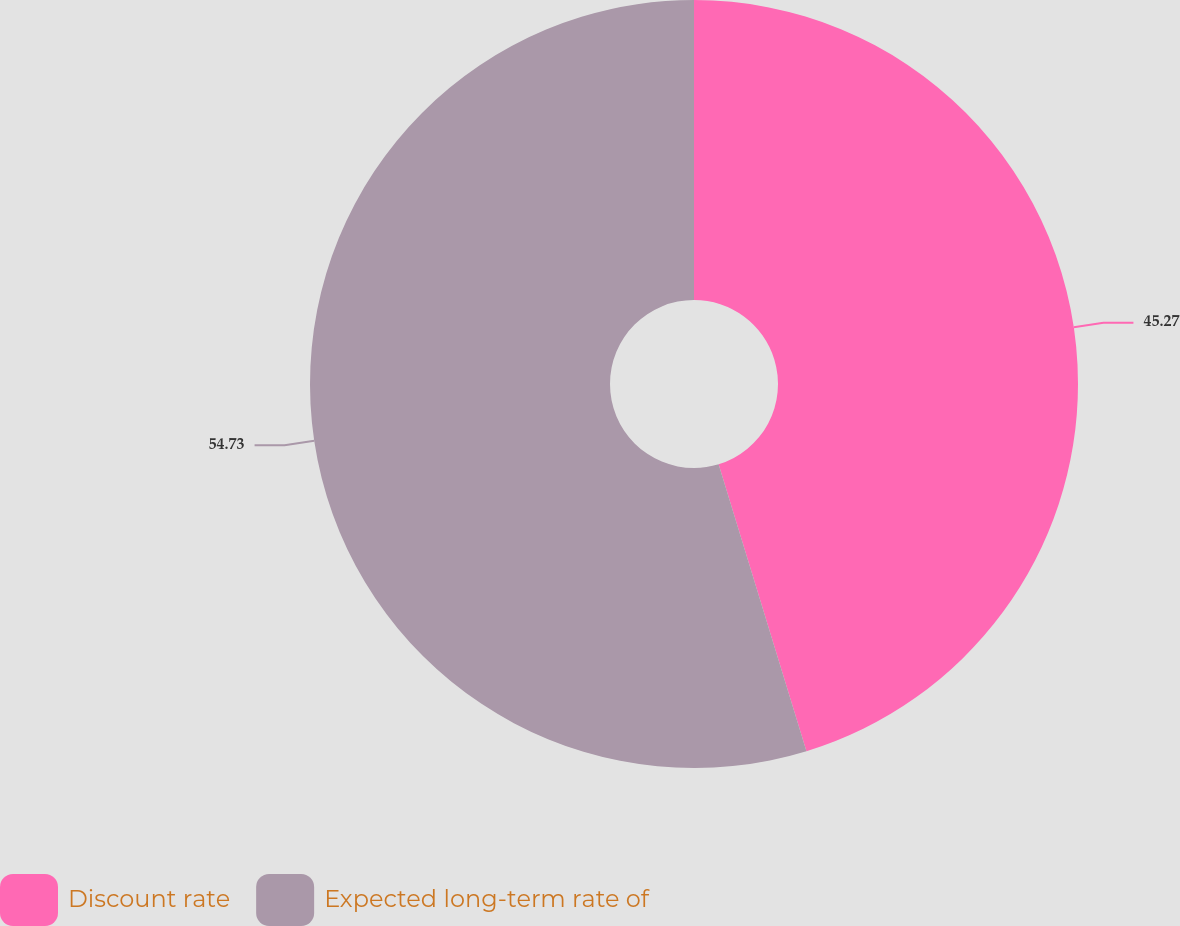Convert chart. <chart><loc_0><loc_0><loc_500><loc_500><pie_chart><fcel>Discount rate<fcel>Expected long-term rate of<nl><fcel>45.27%<fcel>54.73%<nl></chart> 